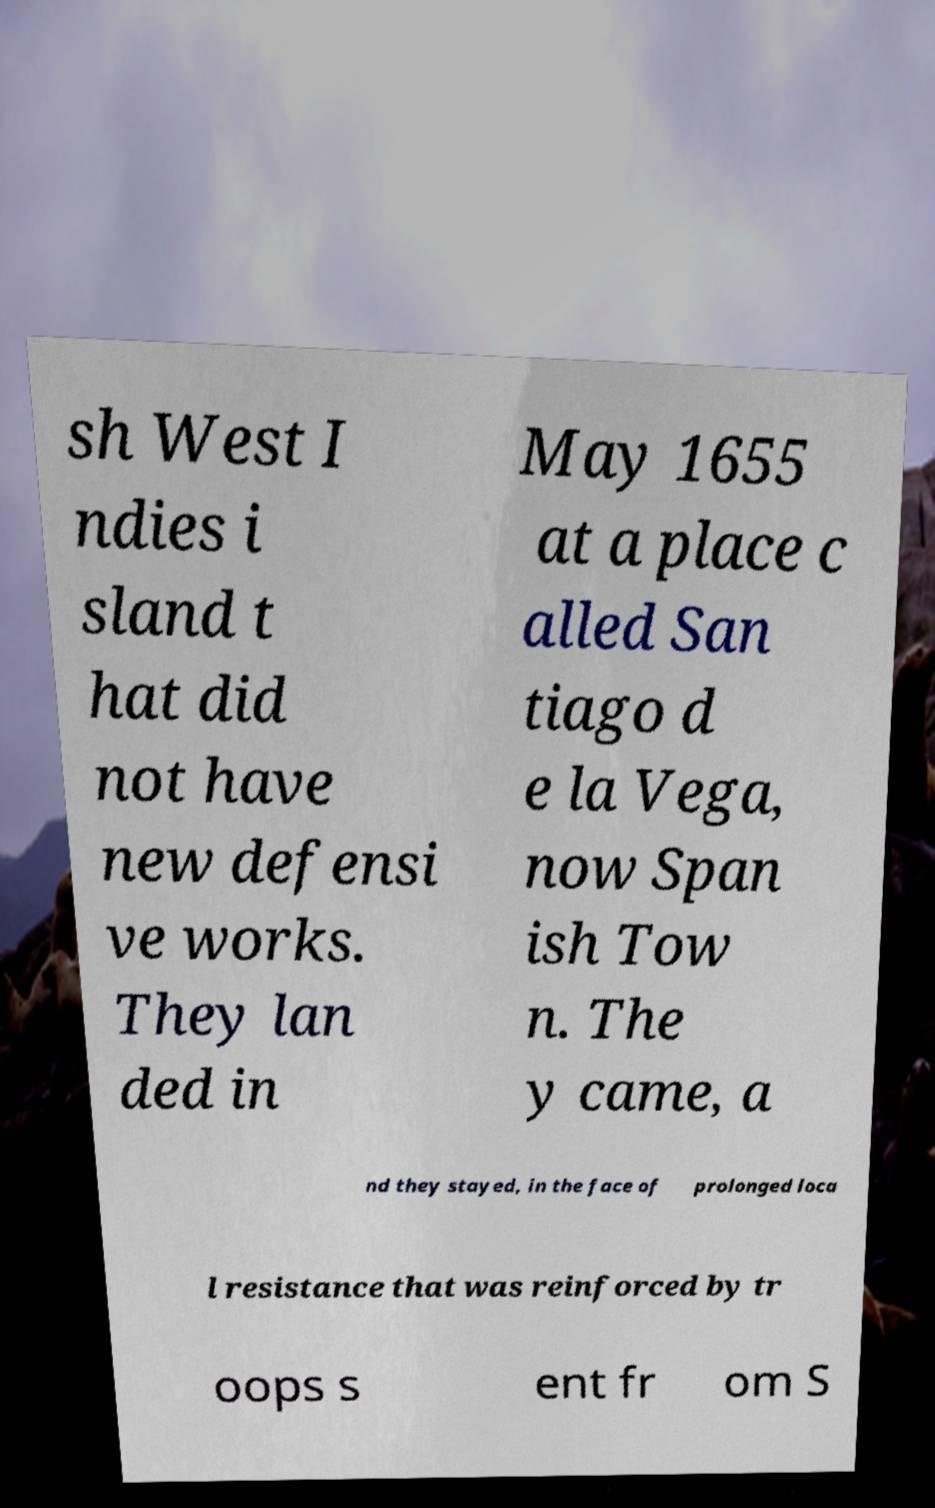Can you read and provide the text displayed in the image?This photo seems to have some interesting text. Can you extract and type it out for me? sh West I ndies i sland t hat did not have new defensi ve works. They lan ded in May 1655 at a place c alled San tiago d e la Vega, now Span ish Tow n. The y came, a nd they stayed, in the face of prolonged loca l resistance that was reinforced by tr oops s ent fr om S 